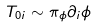Convert formula to latex. <formula><loc_0><loc_0><loc_500><loc_500>T _ { 0 i } \sim \pi _ { \phi } \partial _ { i } \phi</formula> 